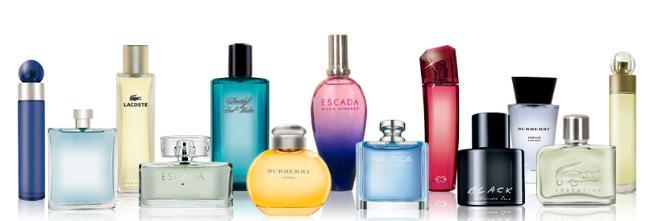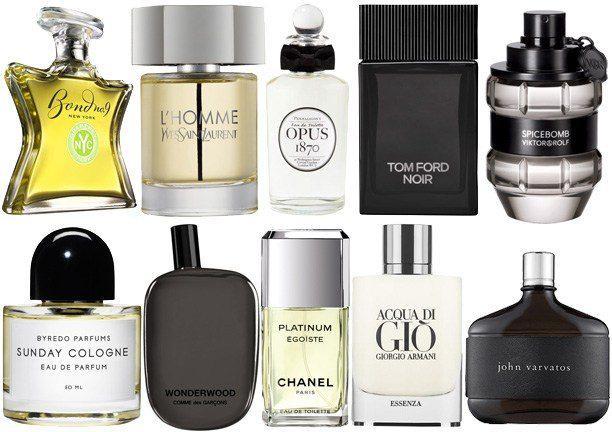The first image is the image on the left, the second image is the image on the right. Assess this claim about the two images: "In both images the products are all of varying heights.". Correct or not? Answer yes or no. No. 